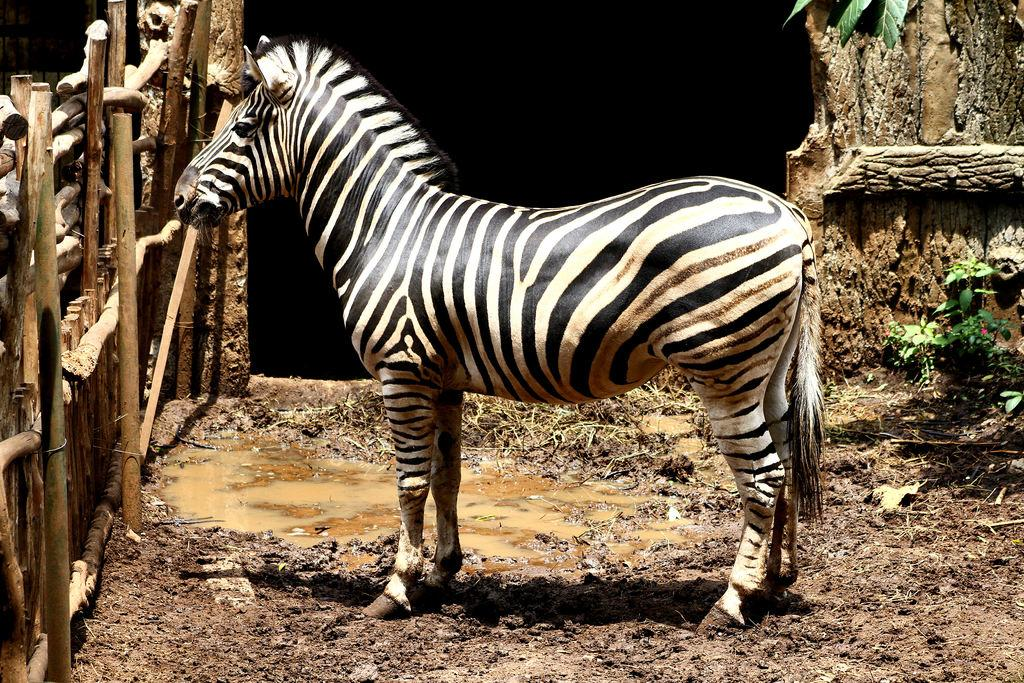What animal is present in the image? There is a zebra in the image. What is the zebra doing in the image? The zebra is standing on the ground in the image. What type of terrain can be seen in the image? There is mud in the image. What type of barrier is visible in the image? There is a wooden fence in the image. What type of vegetation is present in the image? There are plants in the image. How would you describe the lighting in the image? The background of the image is dark. What type of muscle is being exercised by the zebra in the image? There is no indication in the image that the zebra is exercising any muscles. 